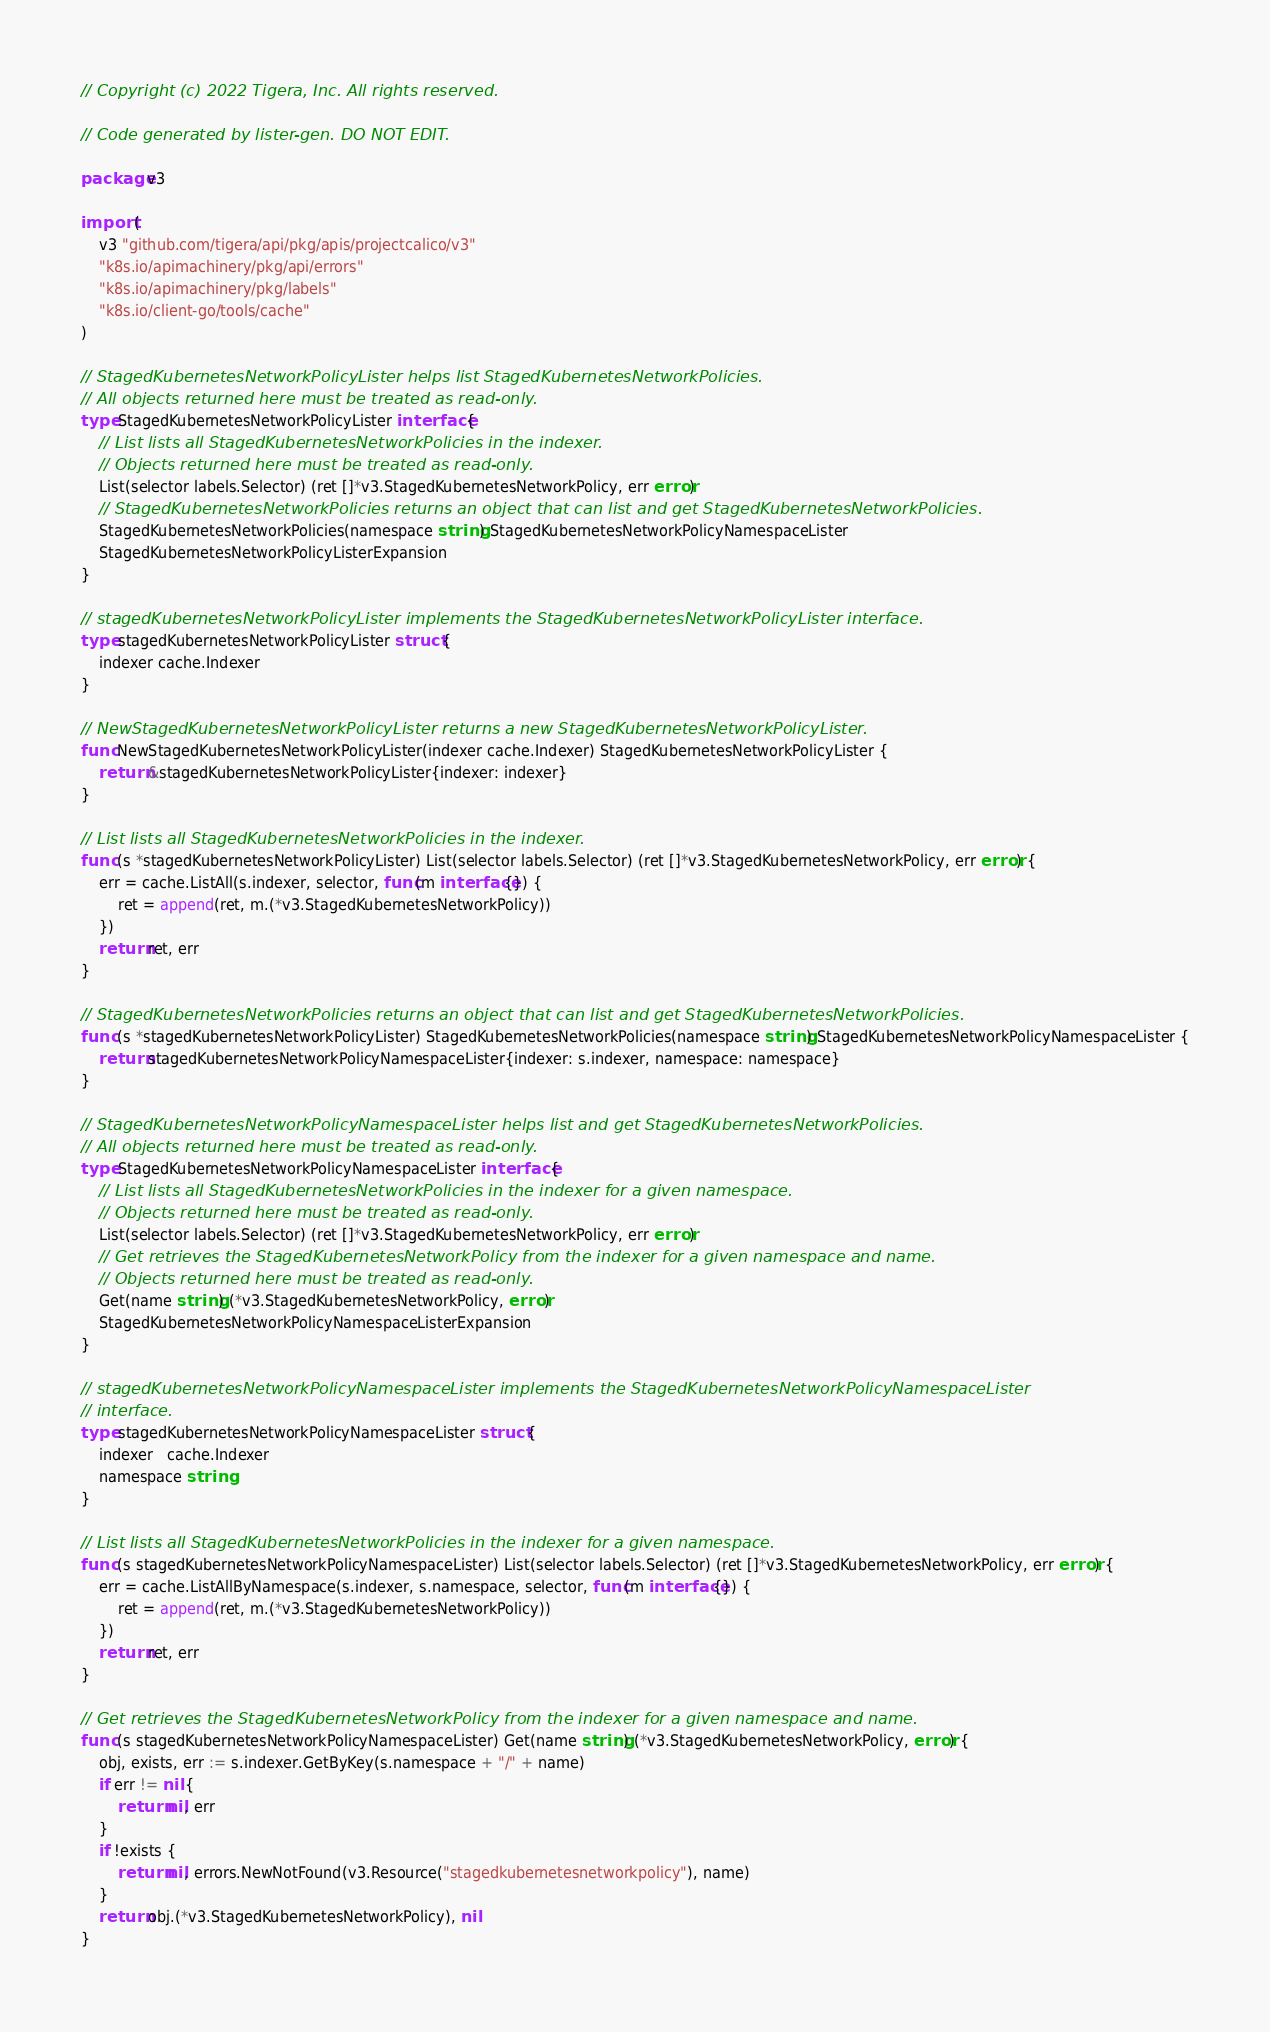Convert code to text. <code><loc_0><loc_0><loc_500><loc_500><_Go_>// Copyright (c) 2022 Tigera, Inc. All rights reserved.

// Code generated by lister-gen. DO NOT EDIT.

package v3

import (
	v3 "github.com/tigera/api/pkg/apis/projectcalico/v3"
	"k8s.io/apimachinery/pkg/api/errors"
	"k8s.io/apimachinery/pkg/labels"
	"k8s.io/client-go/tools/cache"
)

// StagedKubernetesNetworkPolicyLister helps list StagedKubernetesNetworkPolicies.
// All objects returned here must be treated as read-only.
type StagedKubernetesNetworkPolicyLister interface {
	// List lists all StagedKubernetesNetworkPolicies in the indexer.
	// Objects returned here must be treated as read-only.
	List(selector labels.Selector) (ret []*v3.StagedKubernetesNetworkPolicy, err error)
	// StagedKubernetesNetworkPolicies returns an object that can list and get StagedKubernetesNetworkPolicies.
	StagedKubernetesNetworkPolicies(namespace string) StagedKubernetesNetworkPolicyNamespaceLister
	StagedKubernetesNetworkPolicyListerExpansion
}

// stagedKubernetesNetworkPolicyLister implements the StagedKubernetesNetworkPolicyLister interface.
type stagedKubernetesNetworkPolicyLister struct {
	indexer cache.Indexer
}

// NewStagedKubernetesNetworkPolicyLister returns a new StagedKubernetesNetworkPolicyLister.
func NewStagedKubernetesNetworkPolicyLister(indexer cache.Indexer) StagedKubernetesNetworkPolicyLister {
	return &stagedKubernetesNetworkPolicyLister{indexer: indexer}
}

// List lists all StagedKubernetesNetworkPolicies in the indexer.
func (s *stagedKubernetesNetworkPolicyLister) List(selector labels.Selector) (ret []*v3.StagedKubernetesNetworkPolicy, err error) {
	err = cache.ListAll(s.indexer, selector, func(m interface{}) {
		ret = append(ret, m.(*v3.StagedKubernetesNetworkPolicy))
	})
	return ret, err
}

// StagedKubernetesNetworkPolicies returns an object that can list and get StagedKubernetesNetworkPolicies.
func (s *stagedKubernetesNetworkPolicyLister) StagedKubernetesNetworkPolicies(namespace string) StagedKubernetesNetworkPolicyNamespaceLister {
	return stagedKubernetesNetworkPolicyNamespaceLister{indexer: s.indexer, namespace: namespace}
}

// StagedKubernetesNetworkPolicyNamespaceLister helps list and get StagedKubernetesNetworkPolicies.
// All objects returned here must be treated as read-only.
type StagedKubernetesNetworkPolicyNamespaceLister interface {
	// List lists all StagedKubernetesNetworkPolicies in the indexer for a given namespace.
	// Objects returned here must be treated as read-only.
	List(selector labels.Selector) (ret []*v3.StagedKubernetesNetworkPolicy, err error)
	// Get retrieves the StagedKubernetesNetworkPolicy from the indexer for a given namespace and name.
	// Objects returned here must be treated as read-only.
	Get(name string) (*v3.StagedKubernetesNetworkPolicy, error)
	StagedKubernetesNetworkPolicyNamespaceListerExpansion
}

// stagedKubernetesNetworkPolicyNamespaceLister implements the StagedKubernetesNetworkPolicyNamespaceLister
// interface.
type stagedKubernetesNetworkPolicyNamespaceLister struct {
	indexer   cache.Indexer
	namespace string
}

// List lists all StagedKubernetesNetworkPolicies in the indexer for a given namespace.
func (s stagedKubernetesNetworkPolicyNamespaceLister) List(selector labels.Selector) (ret []*v3.StagedKubernetesNetworkPolicy, err error) {
	err = cache.ListAllByNamespace(s.indexer, s.namespace, selector, func(m interface{}) {
		ret = append(ret, m.(*v3.StagedKubernetesNetworkPolicy))
	})
	return ret, err
}

// Get retrieves the StagedKubernetesNetworkPolicy from the indexer for a given namespace and name.
func (s stagedKubernetesNetworkPolicyNamespaceLister) Get(name string) (*v3.StagedKubernetesNetworkPolicy, error) {
	obj, exists, err := s.indexer.GetByKey(s.namespace + "/" + name)
	if err != nil {
		return nil, err
	}
	if !exists {
		return nil, errors.NewNotFound(v3.Resource("stagedkubernetesnetworkpolicy"), name)
	}
	return obj.(*v3.StagedKubernetesNetworkPolicy), nil
}
</code> 